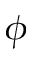<formula> <loc_0><loc_0><loc_500><loc_500>\phi</formula> 